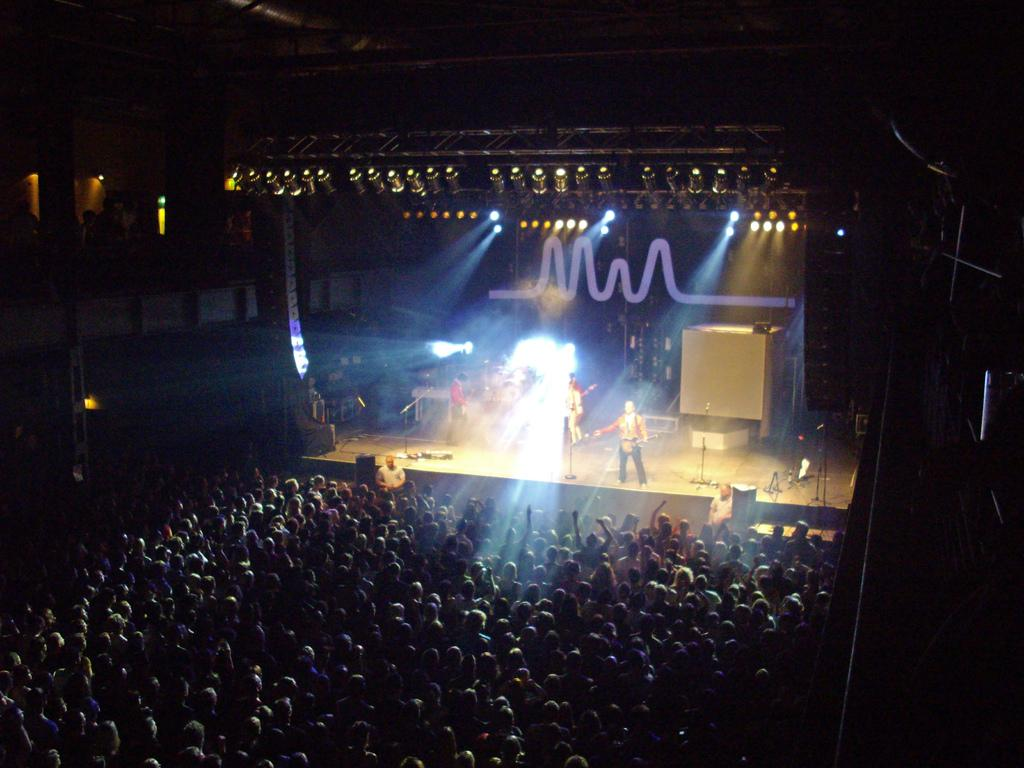What is happening on the stage in the image? There are people on a stage in the image, and they are singing. Who is watching the people on the stage? There are people in front of the stage watching the show. What type of prose is being recited by the people on the stage? There is no mention of prose in the image; the people on the stage are singing. How does the rhythm of the performance affect the people watching the show? The image does not provide information about the rhythm of the performance, so it cannot be determined how it affects the people watching the show. 